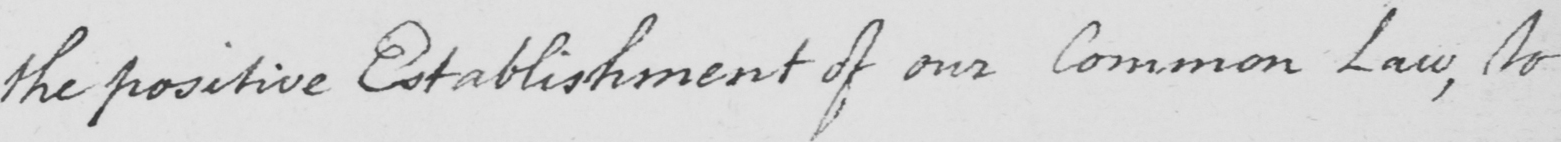Can you read and transcribe this handwriting? the positive Establishment of our Common Law , to 